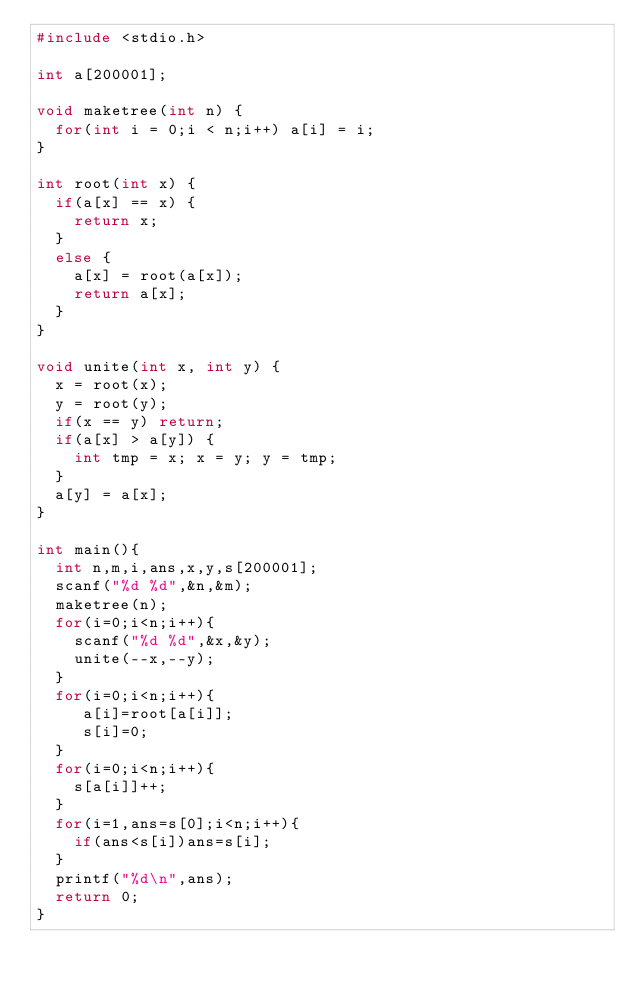Convert code to text. <code><loc_0><loc_0><loc_500><loc_500><_C_>#include <stdio.h>
 
int a[200001];
 
void maketree(int n) {
  for(int i = 0;i < n;i++) a[i] = i;
}
 
int root(int x) {
  if(a[x] == x) {
    return x;
  } 
  else {
    a[x] = root(a[x]);
    return a[x];
  }
}
 
void unite(int x, int y) {
  x = root(x);
  y = root(y);
  if(x == y) return;
  if(a[x] > a[y]) { 
    int tmp = x; x = y; y = tmp; 
  }
  a[y] = a[x];
}
 
int main(){
  int n,m,i,ans,x,y,s[200001];
  scanf("%d %d",&n,&m);
  maketree(n);
  for(i=0;i<n;i++){
    scanf("%d %d",&x,&y);
    unite(--x,--y);
  }
  for(i=0;i<n;i++){
     a[i]=root[a[i]];
     s[i]=0;
  }
  for(i=0;i<n;i++){
    s[a[i]]++;
  }
  for(i=1,ans=s[0];i<n;i++){
    if(ans<s[i])ans=s[i];
  }
  printf("%d\n",ans);
  return 0;
}
</code> 